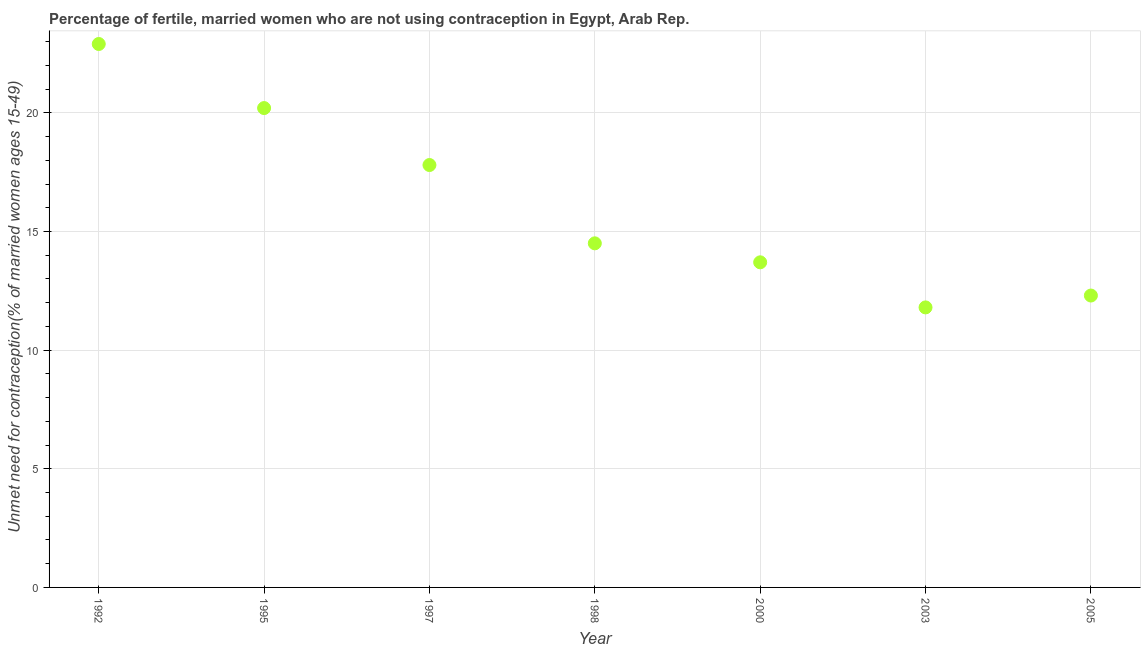What is the number of married women who are not using contraception in 1997?
Offer a very short reply. 17.8. Across all years, what is the maximum number of married women who are not using contraception?
Give a very brief answer. 22.9. Across all years, what is the minimum number of married women who are not using contraception?
Your response must be concise. 11.8. In which year was the number of married women who are not using contraception minimum?
Offer a terse response. 2003. What is the sum of the number of married women who are not using contraception?
Offer a terse response. 113.2. What is the difference between the number of married women who are not using contraception in 1997 and 1998?
Your answer should be compact. 3.3. What is the average number of married women who are not using contraception per year?
Provide a short and direct response. 16.17. What is the median number of married women who are not using contraception?
Offer a terse response. 14.5. In how many years, is the number of married women who are not using contraception greater than 1 %?
Ensure brevity in your answer.  7. Do a majority of the years between 1992 and 1995 (inclusive) have number of married women who are not using contraception greater than 12 %?
Give a very brief answer. Yes. What is the ratio of the number of married women who are not using contraception in 1992 to that in 2003?
Your response must be concise. 1.94. Is the difference between the number of married women who are not using contraception in 2000 and 2003 greater than the difference between any two years?
Provide a succinct answer. No. What is the difference between the highest and the second highest number of married women who are not using contraception?
Offer a terse response. 2.7. Is the sum of the number of married women who are not using contraception in 2000 and 2005 greater than the maximum number of married women who are not using contraception across all years?
Provide a succinct answer. Yes. What is the difference between the highest and the lowest number of married women who are not using contraception?
Give a very brief answer. 11.1. How many years are there in the graph?
Make the answer very short. 7. Does the graph contain grids?
Provide a succinct answer. Yes. What is the title of the graph?
Your response must be concise. Percentage of fertile, married women who are not using contraception in Egypt, Arab Rep. What is the label or title of the X-axis?
Offer a terse response. Year. What is the label or title of the Y-axis?
Ensure brevity in your answer.   Unmet need for contraception(% of married women ages 15-49). What is the  Unmet need for contraception(% of married women ages 15-49) in 1992?
Your response must be concise. 22.9. What is the  Unmet need for contraception(% of married women ages 15-49) in 1995?
Keep it short and to the point. 20.2. What is the  Unmet need for contraception(% of married women ages 15-49) in 1998?
Keep it short and to the point. 14.5. What is the  Unmet need for contraception(% of married women ages 15-49) in 2003?
Your response must be concise. 11.8. What is the difference between the  Unmet need for contraception(% of married women ages 15-49) in 1992 and 1997?
Provide a short and direct response. 5.1. What is the difference between the  Unmet need for contraception(% of married women ages 15-49) in 1992 and 1998?
Your answer should be compact. 8.4. What is the difference between the  Unmet need for contraception(% of married women ages 15-49) in 1992 and 2000?
Your response must be concise. 9.2. What is the difference between the  Unmet need for contraception(% of married women ages 15-49) in 1992 and 2003?
Your response must be concise. 11.1. What is the difference between the  Unmet need for contraception(% of married women ages 15-49) in 1995 and 1998?
Your response must be concise. 5.7. What is the difference between the  Unmet need for contraception(% of married women ages 15-49) in 1995 and 2005?
Your answer should be very brief. 7.9. What is the difference between the  Unmet need for contraception(% of married women ages 15-49) in 1997 and 1998?
Offer a very short reply. 3.3. What is the difference between the  Unmet need for contraception(% of married women ages 15-49) in 1997 and 2003?
Your response must be concise. 6. What is the difference between the  Unmet need for contraception(% of married women ages 15-49) in 1998 and 2003?
Your answer should be compact. 2.7. What is the difference between the  Unmet need for contraception(% of married women ages 15-49) in 2000 and 2005?
Give a very brief answer. 1.4. What is the difference between the  Unmet need for contraception(% of married women ages 15-49) in 2003 and 2005?
Ensure brevity in your answer.  -0.5. What is the ratio of the  Unmet need for contraception(% of married women ages 15-49) in 1992 to that in 1995?
Provide a succinct answer. 1.13. What is the ratio of the  Unmet need for contraception(% of married women ages 15-49) in 1992 to that in 1997?
Your response must be concise. 1.29. What is the ratio of the  Unmet need for contraception(% of married women ages 15-49) in 1992 to that in 1998?
Your answer should be compact. 1.58. What is the ratio of the  Unmet need for contraception(% of married women ages 15-49) in 1992 to that in 2000?
Ensure brevity in your answer.  1.67. What is the ratio of the  Unmet need for contraception(% of married women ages 15-49) in 1992 to that in 2003?
Your response must be concise. 1.94. What is the ratio of the  Unmet need for contraception(% of married women ages 15-49) in 1992 to that in 2005?
Provide a short and direct response. 1.86. What is the ratio of the  Unmet need for contraception(% of married women ages 15-49) in 1995 to that in 1997?
Your answer should be compact. 1.14. What is the ratio of the  Unmet need for contraception(% of married women ages 15-49) in 1995 to that in 1998?
Make the answer very short. 1.39. What is the ratio of the  Unmet need for contraception(% of married women ages 15-49) in 1995 to that in 2000?
Offer a terse response. 1.47. What is the ratio of the  Unmet need for contraception(% of married women ages 15-49) in 1995 to that in 2003?
Make the answer very short. 1.71. What is the ratio of the  Unmet need for contraception(% of married women ages 15-49) in 1995 to that in 2005?
Ensure brevity in your answer.  1.64. What is the ratio of the  Unmet need for contraception(% of married women ages 15-49) in 1997 to that in 1998?
Offer a terse response. 1.23. What is the ratio of the  Unmet need for contraception(% of married women ages 15-49) in 1997 to that in 2000?
Your response must be concise. 1.3. What is the ratio of the  Unmet need for contraception(% of married women ages 15-49) in 1997 to that in 2003?
Provide a succinct answer. 1.51. What is the ratio of the  Unmet need for contraception(% of married women ages 15-49) in 1997 to that in 2005?
Your answer should be very brief. 1.45. What is the ratio of the  Unmet need for contraception(% of married women ages 15-49) in 1998 to that in 2000?
Your response must be concise. 1.06. What is the ratio of the  Unmet need for contraception(% of married women ages 15-49) in 1998 to that in 2003?
Provide a succinct answer. 1.23. What is the ratio of the  Unmet need for contraception(% of married women ages 15-49) in 1998 to that in 2005?
Your answer should be compact. 1.18. What is the ratio of the  Unmet need for contraception(% of married women ages 15-49) in 2000 to that in 2003?
Offer a terse response. 1.16. What is the ratio of the  Unmet need for contraception(% of married women ages 15-49) in 2000 to that in 2005?
Your answer should be very brief. 1.11. What is the ratio of the  Unmet need for contraception(% of married women ages 15-49) in 2003 to that in 2005?
Your response must be concise. 0.96. 